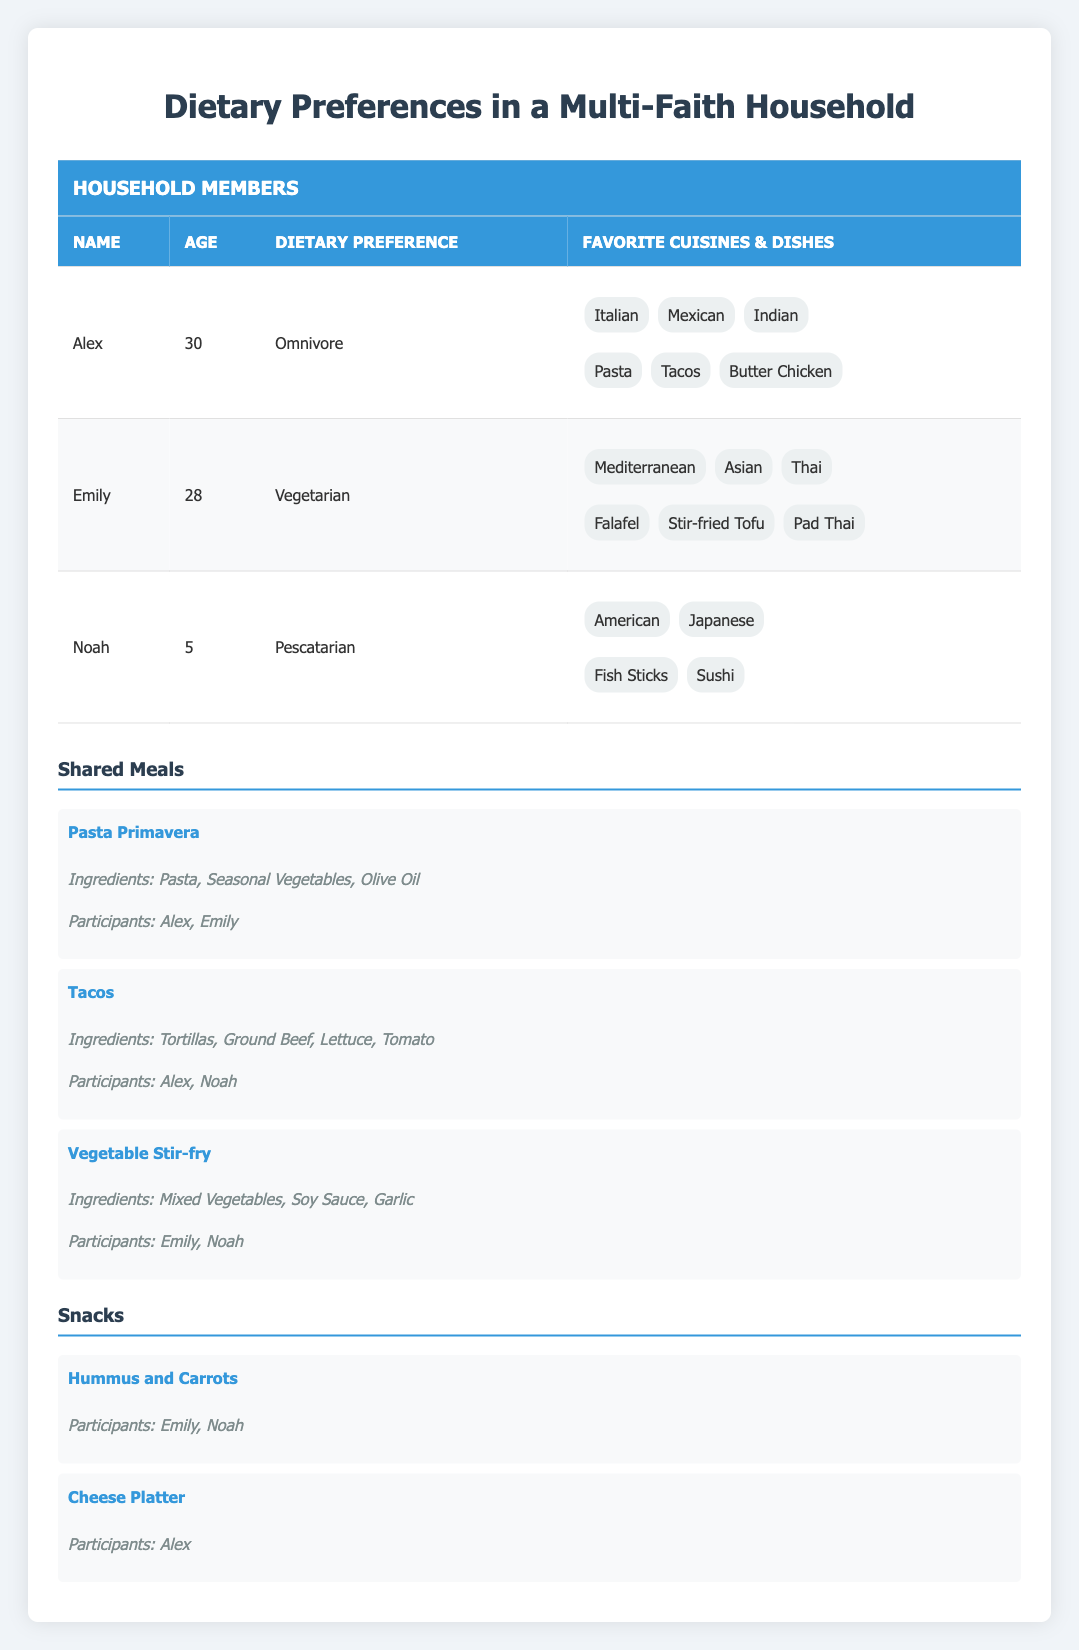What are Alex's favorite cuisines? From the table, we can look at Alex's dietary preferences and find that his favorite cuisines are listed as Italian, Mexican, and Indian.
Answer: Italian, Mexican, Indian How many members in the household have vegetarian dietary preferences? By examining the table, we see that there is one member, Emily, who follows a vegetarian diet.
Answer: 1 Which shared meal includes participants from both Alex and Emily? Looking at the shared meals, the table shows that "Pasta Primavera" involves both Alex and Emily as participants.
Answer: Pasta Primavera Is there a shared meal that involves only Noah? The table indicates that there are no shared meals where Noah is a participant on his own; he is always accompanied by Alex or Emily.
Answer: No What is the total number of favorite cuisines listed for all household members? We can calculate by adding the favorite cuisines for each member: Alex has 3, Emily has 3, and Noah has 2, totaling 3 + 3 + 2 = 8.
Answer: 8 Which dietary preference type is most prominent in the household based on the table? Reviewing the various dietary preferences listed: Omnivore (Alex), Vegetarian (Emily), and Pescatarian (Noah) indicate that there's no single type that is most common since all types are represented by one person each.
Answer: None For Emily, how many specific dishes are listed? The table shows that Emily has 3 specific dishes listed, namely Falafel, Stir-fried Tofu, and Pad Thai.
Answer: 3 Which meal has the most ingredients and how many are there? By analyzing the shared meals, "Tacos" and "Vegetable Stir-fry" both have 4 ingredients, while "Pasta Primavera" has 3. The meals with the most ingredients are Tacos and Vegetable Stir-fry, each with 4 ingredients.
Answer: Tacos, Vegetable Stir-fry, 4 Are there any snacks that both Emily and Noah enjoy together? According to the table, the snack "Hummus and Carrots" is listed as enjoyed by both Emily and Noah.
Answer: Yes 